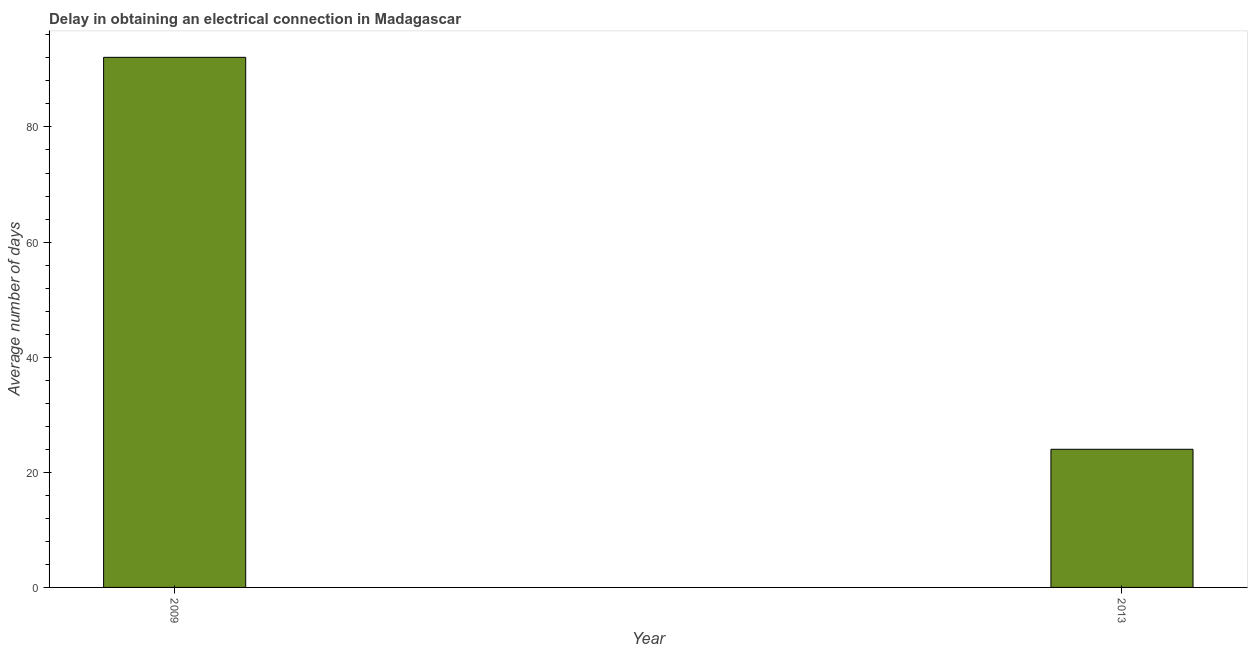Does the graph contain any zero values?
Offer a terse response. No. What is the title of the graph?
Offer a very short reply. Delay in obtaining an electrical connection in Madagascar. What is the label or title of the X-axis?
Your response must be concise. Year. What is the label or title of the Y-axis?
Provide a short and direct response. Average number of days. What is the dalay in electrical connection in 2009?
Offer a very short reply. 92.1. Across all years, what is the maximum dalay in electrical connection?
Offer a terse response. 92.1. Across all years, what is the minimum dalay in electrical connection?
Your answer should be compact. 24. In which year was the dalay in electrical connection maximum?
Keep it short and to the point. 2009. In which year was the dalay in electrical connection minimum?
Offer a very short reply. 2013. What is the sum of the dalay in electrical connection?
Give a very brief answer. 116.1. What is the difference between the dalay in electrical connection in 2009 and 2013?
Your response must be concise. 68.1. What is the average dalay in electrical connection per year?
Offer a terse response. 58.05. What is the median dalay in electrical connection?
Offer a very short reply. 58.05. Do a majority of the years between 2009 and 2013 (inclusive) have dalay in electrical connection greater than 20 days?
Provide a succinct answer. Yes. What is the ratio of the dalay in electrical connection in 2009 to that in 2013?
Make the answer very short. 3.84. In how many years, is the dalay in electrical connection greater than the average dalay in electrical connection taken over all years?
Your response must be concise. 1. Are all the bars in the graph horizontal?
Provide a succinct answer. No. How many years are there in the graph?
Offer a very short reply. 2. What is the Average number of days in 2009?
Your answer should be very brief. 92.1. What is the difference between the Average number of days in 2009 and 2013?
Ensure brevity in your answer.  68.1. What is the ratio of the Average number of days in 2009 to that in 2013?
Offer a terse response. 3.84. 